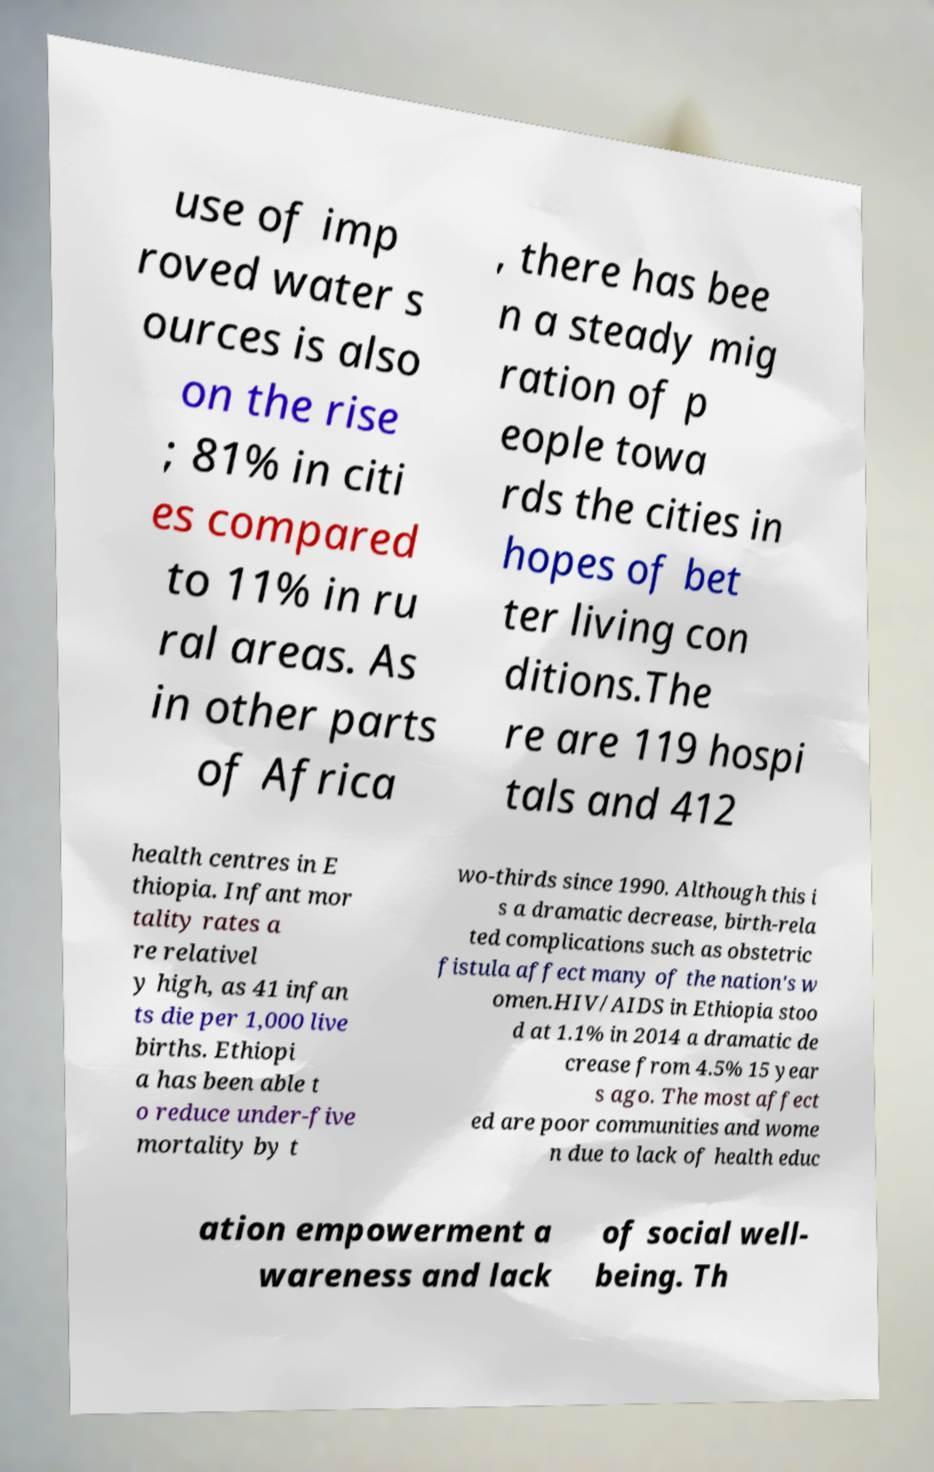I need the written content from this picture converted into text. Can you do that? use of imp roved water s ources is also on the rise ; 81% in citi es compared to 11% in ru ral areas. As in other parts of Africa , there has bee n a steady mig ration of p eople towa rds the cities in hopes of bet ter living con ditions.The re are 119 hospi tals and 412 health centres in E thiopia. Infant mor tality rates a re relativel y high, as 41 infan ts die per 1,000 live births. Ethiopi a has been able t o reduce under-five mortality by t wo-thirds since 1990. Although this i s a dramatic decrease, birth-rela ted complications such as obstetric fistula affect many of the nation's w omen.HIV/AIDS in Ethiopia stoo d at 1.1% in 2014 a dramatic de crease from 4.5% 15 year s ago. The most affect ed are poor communities and wome n due to lack of health educ ation empowerment a wareness and lack of social well- being. Th 